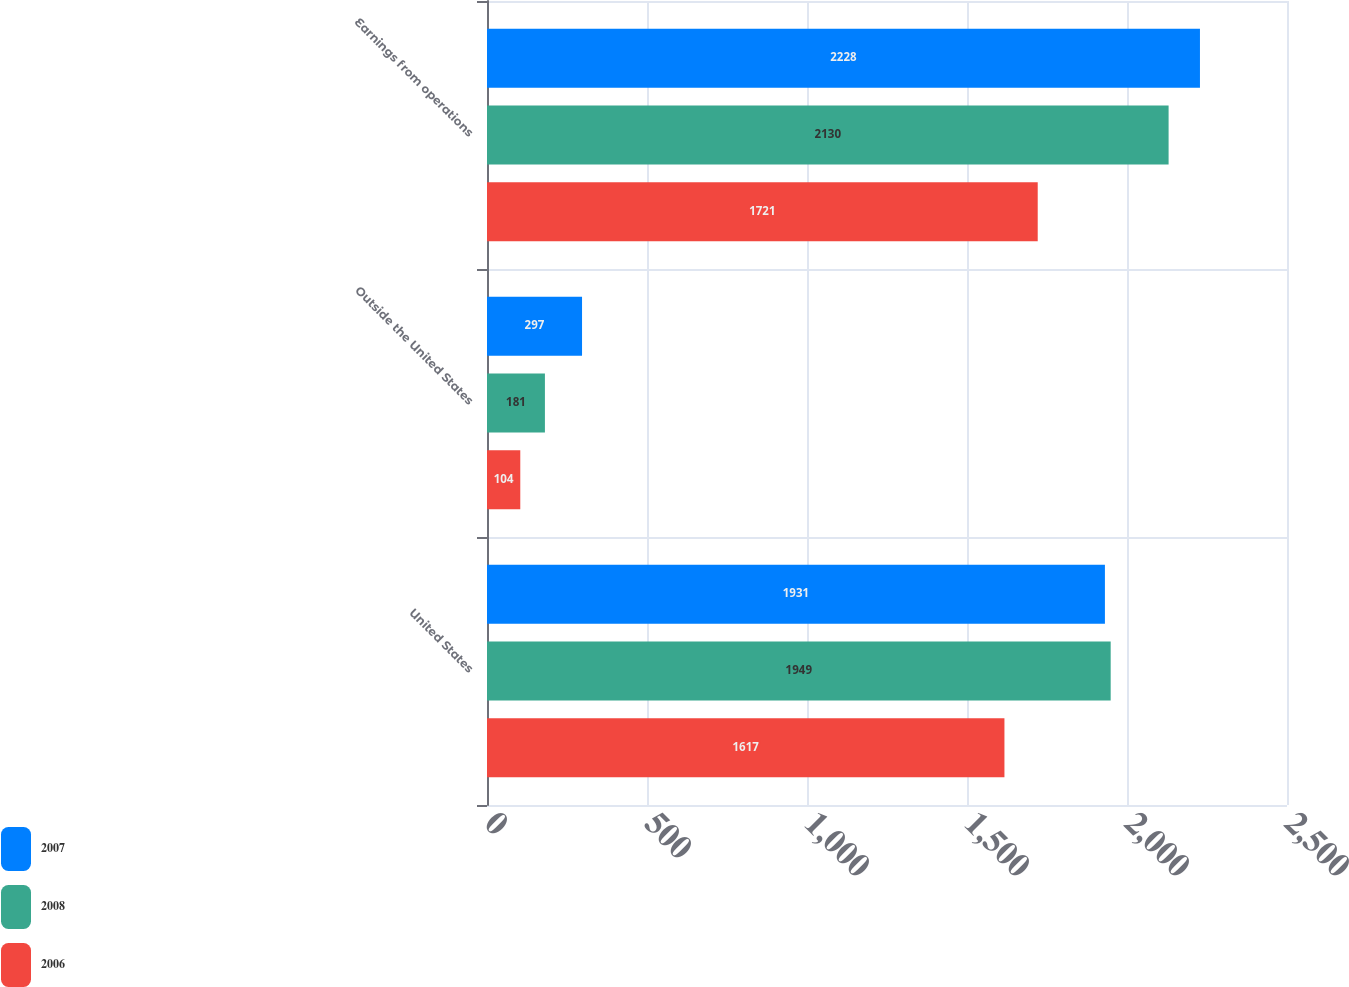<chart> <loc_0><loc_0><loc_500><loc_500><stacked_bar_chart><ecel><fcel>United States<fcel>Outside the United States<fcel>Earnings from operations<nl><fcel>2007<fcel>1931<fcel>297<fcel>2228<nl><fcel>2008<fcel>1949<fcel>181<fcel>2130<nl><fcel>2006<fcel>1617<fcel>104<fcel>1721<nl></chart> 